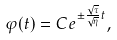Convert formula to latex. <formula><loc_0><loc_0><loc_500><loc_500>\varphi ( t ) = C e ^ { \pm \frac { \sqrt { \tau } } { \sqrt { \eta } } t } ,</formula> 